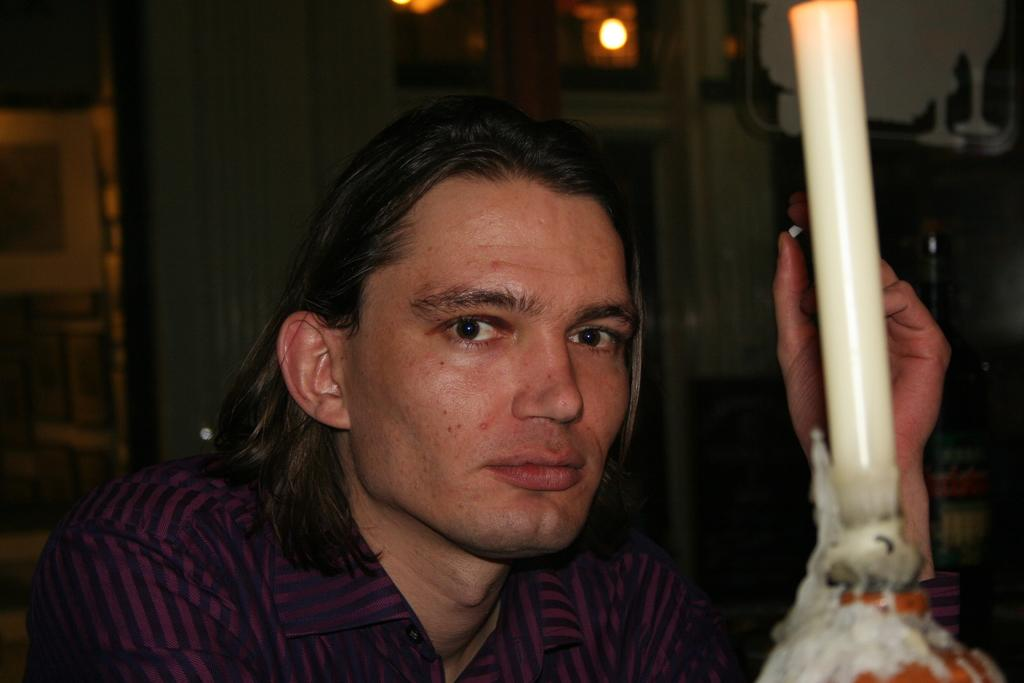What is the main object in the foreground of the image? There is a candle in the foreground of the image. Who or what is behind the candle? There is a man behind the candle. What can be seen in the background of the image? There is a light, a wall, and other objects visible in the background of the image. Can you describe the wall in the background? The wall is in the background of the image, but no specific details about its appearance are provided. What type of minister is standing next to the cows in the image? There are no ministers or cows present in the image. What color is the flag flying in the background of the image? There is no flag visible in the background of the image. 